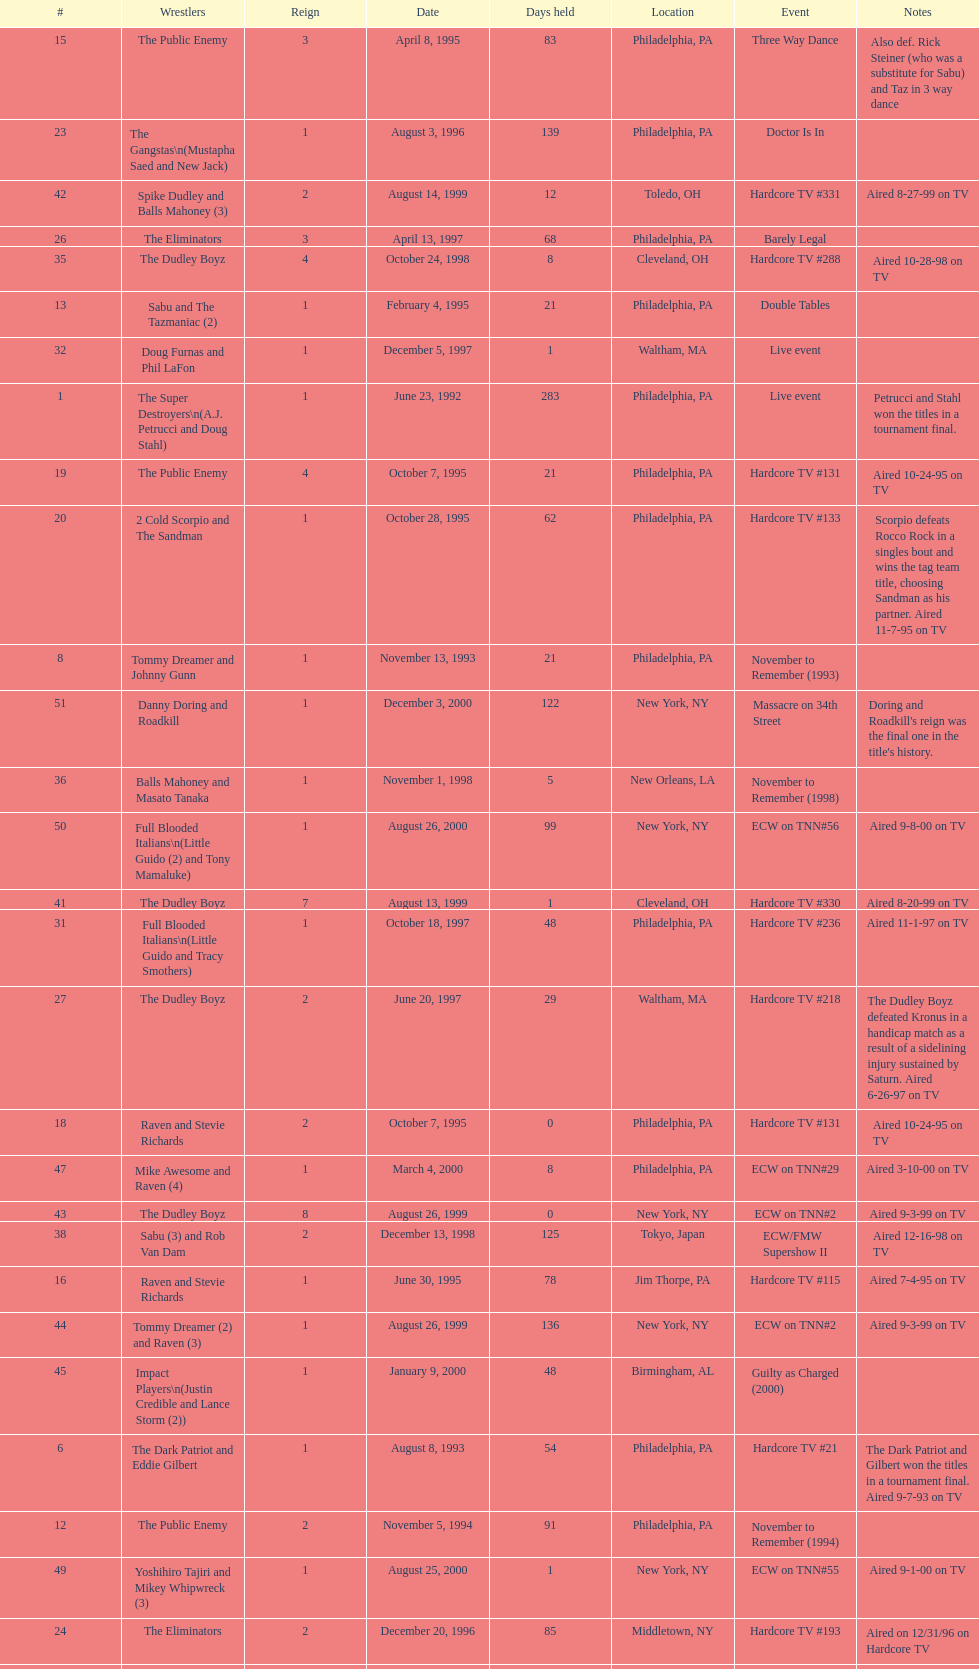Which was the only squad to triumph by forfeit? The Dudley Boyz. Could you parse the entire table? {'header': ['#', 'Wrestlers', 'Reign', 'Date', 'Days held', 'Location', 'Event', 'Notes'], 'rows': [['15', 'The Public Enemy', '3', 'April 8, 1995', '83', 'Philadelphia, PA', 'Three Way Dance', 'Also def. Rick Steiner (who was a substitute for Sabu) and Taz in 3 way dance'], ['23', 'The Gangstas\\n(Mustapha Saed and New Jack)', '1', 'August 3, 1996', '139', 'Philadelphia, PA', 'Doctor Is In', ''], ['42', 'Spike Dudley and Balls Mahoney (3)', '2', 'August 14, 1999', '12', 'Toledo, OH', 'Hardcore TV #331', 'Aired 8-27-99 on TV'], ['26', 'The Eliminators', '3', 'April 13, 1997', '68', 'Philadelphia, PA', 'Barely Legal', ''], ['35', 'The Dudley Boyz', '4', 'October 24, 1998', '8', 'Cleveland, OH', 'Hardcore TV #288', 'Aired 10-28-98 on TV'], ['13', 'Sabu and The Tazmaniac (2)', '1', 'February 4, 1995', '21', 'Philadelphia, PA', 'Double Tables', ''], ['32', 'Doug Furnas and Phil LaFon', '1', 'December 5, 1997', '1', 'Waltham, MA', 'Live event', ''], ['1', 'The Super Destroyers\\n(A.J. Petrucci and Doug Stahl)', '1', 'June 23, 1992', '283', 'Philadelphia, PA', 'Live event', 'Petrucci and Stahl won the titles in a tournament final.'], ['19', 'The Public Enemy', '4', 'October 7, 1995', '21', 'Philadelphia, PA', 'Hardcore TV #131', 'Aired 10-24-95 on TV'], ['20', '2 Cold Scorpio and The Sandman', '1', 'October 28, 1995', '62', 'Philadelphia, PA', 'Hardcore TV #133', 'Scorpio defeats Rocco Rock in a singles bout and wins the tag team title, choosing Sandman as his partner. Aired 11-7-95 on TV'], ['8', 'Tommy Dreamer and Johnny Gunn', '1', 'November 13, 1993', '21', 'Philadelphia, PA', 'November to Remember (1993)', ''], ['51', 'Danny Doring and Roadkill', '1', 'December 3, 2000', '122', 'New York, NY', 'Massacre on 34th Street', "Doring and Roadkill's reign was the final one in the title's history."], ['36', 'Balls Mahoney and Masato Tanaka', '1', 'November 1, 1998', '5', 'New Orleans, LA', 'November to Remember (1998)', ''], ['50', 'Full Blooded Italians\\n(Little Guido (2) and Tony Mamaluke)', '1', 'August 26, 2000', '99', 'New York, NY', 'ECW on TNN#56', 'Aired 9-8-00 on TV'], ['41', 'The Dudley Boyz', '7', 'August 13, 1999', '1', 'Cleveland, OH', 'Hardcore TV #330', 'Aired 8-20-99 on TV'], ['31', 'Full Blooded Italians\\n(Little Guido and Tracy Smothers)', '1', 'October 18, 1997', '48', 'Philadelphia, PA', 'Hardcore TV #236', 'Aired 11-1-97 on TV'], ['27', 'The Dudley Boyz', '2', 'June 20, 1997', '29', 'Waltham, MA', 'Hardcore TV #218', 'The Dudley Boyz defeated Kronus in a handicap match as a result of a sidelining injury sustained by Saturn. Aired 6-26-97 on TV'], ['18', 'Raven and Stevie Richards', '2', 'October 7, 1995', '0', 'Philadelphia, PA', 'Hardcore TV #131', 'Aired 10-24-95 on TV'], ['47', 'Mike Awesome and Raven (4)', '1', 'March 4, 2000', '8', 'Philadelphia, PA', 'ECW on TNN#29', 'Aired 3-10-00 on TV'], ['43', 'The Dudley Boyz', '8', 'August 26, 1999', '0', 'New York, NY', 'ECW on TNN#2', 'Aired 9-3-99 on TV'], ['38', 'Sabu (3) and Rob Van Dam', '2', 'December 13, 1998', '125', 'Tokyo, Japan', 'ECW/FMW Supershow II', 'Aired 12-16-98 on TV'], ['16', 'Raven and Stevie Richards', '1', 'June 30, 1995', '78', 'Jim Thorpe, PA', 'Hardcore TV #115', 'Aired 7-4-95 on TV'], ['44', 'Tommy Dreamer (2) and Raven (3)', '1', 'August 26, 1999', '136', 'New York, NY', 'ECW on TNN#2', 'Aired 9-3-99 on TV'], ['45', 'Impact Players\\n(Justin Credible and Lance Storm (2))', '1', 'January 9, 2000', '48', 'Birmingham, AL', 'Guilty as Charged (2000)', ''], ['6', 'The Dark Patriot and Eddie Gilbert', '1', 'August 8, 1993', '54', 'Philadelphia, PA', 'Hardcore TV #21', 'The Dark Patriot and Gilbert won the titles in a tournament final. Aired 9-7-93 on TV'], ['12', 'The Public Enemy', '2', 'November 5, 1994', '91', 'Philadelphia, PA', 'November to Remember (1994)', ''], ['49', 'Yoshihiro Tajiri and Mikey Whipwreck (3)', '1', 'August 25, 2000', '1', 'New York, NY', 'ECW on TNN#55', 'Aired 9-1-00 on TV'], ['24', 'The Eliminators', '2', 'December 20, 1996', '85', 'Middletown, NY', 'Hardcore TV #193', 'Aired on 12/31/96 on Hardcore TV'], ['40', 'Spike Dudley and Balls Mahoney (2)', '1', 'July 18, 1999', '26', 'Dayton, OH', 'Heat Wave (1999)', ''], ['4', 'The Super Destroyers', '2', 'May 15, 1993', '0', 'Philadelphia, PA', 'Hardcore TV #14', 'Aired 7-6-93 on TV'], ['46', 'Tommy Dreamer (3) and Masato Tanaka (2)', '1', 'February 26, 2000', '7', 'Cincinnati, OH', 'Hardcore TV #358', 'Aired 3-7-00 on TV'], ['37', 'The Dudley Boyz', '5', 'November 6, 1998', '37', 'New York, NY', 'Hardcore TV #290', 'Aired 11-11-98 on TV'], ['—', 'Vacated', '2', 'October 1, 1993', '0', 'Philadelphia, PA', 'Bloodfest: Part 1', 'ECW vacated the championships after The Dark Patriot and Eddie Gilbert left the organization.'], ['14', 'Chris Benoit and Dean Malenko', '1', 'February 25, 1995', '42', 'Philadelphia, PA', 'Return of the Funker', ''], ['21', 'Cactus Jack and Mikey Whipwreck', '2', 'December 29, 1995', '36', 'New York, NY', 'Holiday Hell 1995', "Whipwreck defeated 2 Cold Scorpio in a singles match to win both the tag team titles and the ECW World Television Championship; Cactus Jack came out and declared himself to be Mikey's partner after he won the match."], ['48', 'Impact Players\\n(Justin Credible and Lance Storm (3))', '2', 'March 12, 2000', '31', 'Danbury, CT', 'Living Dangerously', ''], ['22', 'The Eliminators\\n(Kronus and Saturn)', '1', 'February 3, 1996', '182', 'New York, NY', 'Big Apple Blizzard Blast', ''], ['17', 'The Pitbulls\\n(Pitbull #1 and Pitbull #2)', '1', 'September 16, 1995', '21', 'Philadelphia, PA', "Gangsta's Paradise", ''], ['10', 'The Public Enemy\\n(Johnny Grunge and Rocco Rock)', '1', 'March 6, 1994', '174', 'Philadelphia, PA', 'Hardcore TV #46', 'Aired 3-8-94 on TV'], ['29', 'The Dudley Boyz', '3', 'August 17, 1997', '95', 'Fort Lauderdale, FL', 'Hardcore Heaven (1997)', 'The Dudley Boyz won the championship via forfeit as a result of Mustapha Saed leaving the promotion before Hardcore Heaven took place.'], ['33', 'Chris Candido (3) and Lance Storm', '1', 'December 6, 1997', '203', 'Philadelphia, PA', 'Better than Ever', ''], ['5', 'The Suicide Blondes', '2', 'May 15, 1993', '46', 'Philadelphia, PA', 'Hardcore TV #15', 'Aired 7-20-93 on TV'], ['—', 'Vacated', '1', 'July 1993', '39', 'N/A', 'N/A', 'ECW vacated the title after Candido left the promotion for the Smoky Mountain Wrestling organization.'], ['3', 'The Suicide Blondes\\n(Chris Candido, Johnny Hotbody, and Chris Michaels)', '1', 'April 3, 1993', '42', 'Philadelphia, PA', 'Hardcore TV #8', 'All three wrestlers were recognized as champions, and were able to defend the titles in any combination via the Freebird rule. Aired 5-25-93 on TV'], ['25', 'The Dudley Boyz\\n(Buh Buh Ray Dudley and D-Von Dudley)', '1', 'March 15, 1997', '29', 'Philadelphia, PA', 'Hostile City Showdown', 'Aired 3/20/97 on Hardcore TV'], ['39', 'The Dudley Boyz', '6', 'April 17, 1999', '92', 'Buffalo, NY', 'Hardcore TV #313', 'D-Von Dudley defeated Van Dam in a singles match to win the championship for his team. Aired 4-23-99 on TV'], ['11', 'Cactus Jack and Mikey Whipwreck', '1', 'August 27, 1994', '70', 'Philadelphia, PA', 'Hardcore TV #72', 'Whipwreck was a substitute for Terry Funk, who left the company. Aired 9-13-94 on TV'], ['34', 'Sabu (2) and Rob Van Dam', '1', 'June 27, 1998', '119', 'Philadelphia, PA', 'Hardcore TV #271', 'Aired 7-1-98 on TV'], ['7', 'Johnny Hotbody (3) and Tony Stetson (2)', '1', 'October 1, 1993', '43', 'Philadelphia, PA', 'Bloodfest: Part 1', 'Hotbody and Stetson were awarded the titles by ECW.'], ['28', 'The Gangstas', '2', 'July 19, 1997', '29', 'Philadelphia, PA', 'Heat Wave 1997/Hardcore TV #222', 'Aired 7-24-97 on TV'], ['9', 'Kevin Sullivan and The Tazmaniac', '1', 'December 4, 1993', '92', 'Philadelphia, PA', 'Hardcore TV #35', 'Defeat Dreamer and Shane Douglas, who was substituting for an injured Gunn. After the bout, Douglas turned against Dreamer and became a heel. Aired 12-14-93 on TV'], ['2', 'Tony Stetson and Larry Winters', '1', 'April 2, 1993', '1', 'Radnor, PA', 'Hardcore TV #6', 'Aired 5-11-93 on TV'], ['—', 'Vacated', '3', 'April 22, 2000', '125', 'Philadelphia, PA', 'Live event', 'At CyberSlam, Justin Credible threw down the titles to become eligible for the ECW World Heavyweight Championship. Storm later left for World Championship Wrestling. As a result of the circumstances, Credible vacated the championship.'], ['30', 'The Gangstanators\\n(Kronus (4) and New Jack (3))', '1', 'September 20, 1997', '28', 'Philadelphia, PA', 'As Good as it Gets', 'Aired 9-27-97 on TV']]} 